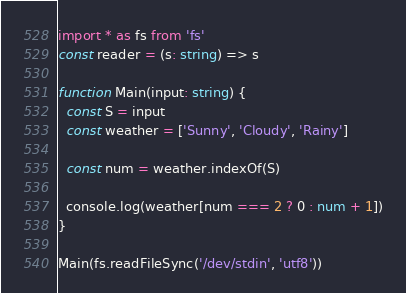<code> <loc_0><loc_0><loc_500><loc_500><_TypeScript_>import * as fs from 'fs'
const reader = (s: string) => s

function Main(input: string) {
  const S = input
  const weather = ['Sunny', 'Cloudy', 'Rainy']

  const num = weather.indexOf(S)

  console.log(weather[num === 2 ? 0 : num + 1])
}

Main(fs.readFileSync('/dev/stdin', 'utf8'))

</code> 